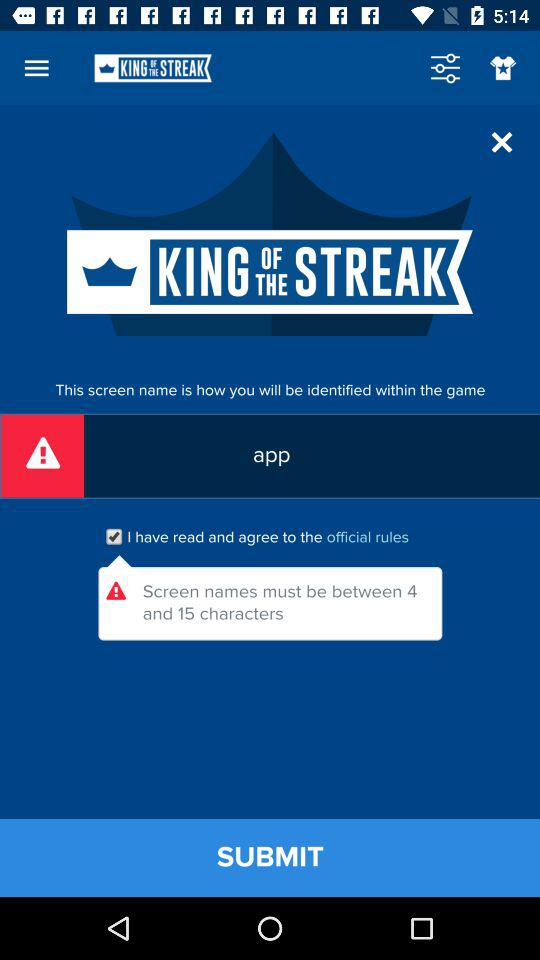What is the application name? The application name is "KING OF THE STREAK". 